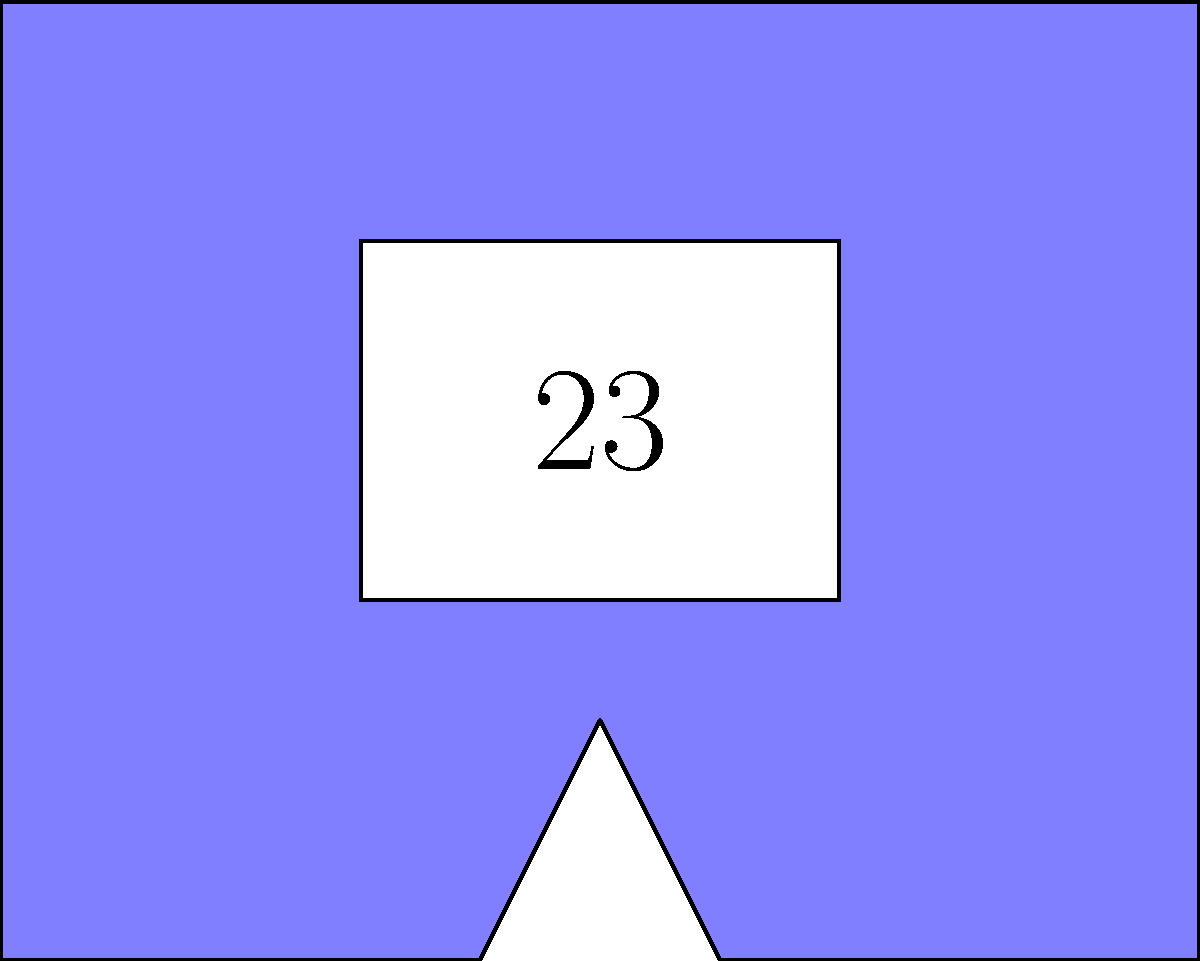In the image above, a basketball jersey design is shown with the star player's number 23. If the jersey is reflected across the vertical line passing through its center, which of the following statements about the reflected image is true?

A) The reflected number will read as 32
B) The reflected jersey will be congruent to the original
C) The reflected jersey will be similar but not congruent to the original
D) The reflection will create an asymmetrical design Let's analyze this step-by-step:

1) The image shows a basketball jersey with the number 23 on it.

2) A reflection is a type of transformation that creates a mirror image across a line of reflection. In this case, the line of reflection is the vertical line passing through the center of the jersey.

3) Properties of reflection:
   a) Reflection preserves size and shape.
   b) The distance from any point to the line of reflection is equal to the distance from its image to the line of reflection.
   c) The line of reflection is the perpendicular bisector of the line segment joining any point to its image.

4) Given these properties, we can conclude that:
   a) The reflected jersey will have exactly the same size and shape as the original jersey.
   b) The number on the reflected jersey will appear backwards, as it's a mirror image. So, 23 will still look like 23, just reversed.

5) The definition of congruent figures in geometry is that they have the same size and shape. Since reflection preserves both size and shape, the reflected jersey will be congruent to the original.

6) The reflection will not create an asymmetrical design. In fact, the reflection along with the original jersey will create a symmetrical design with the line of reflection as the axis of symmetry.

Therefore, the correct statement is that the reflected jersey will be congruent to the original.
Answer: B 